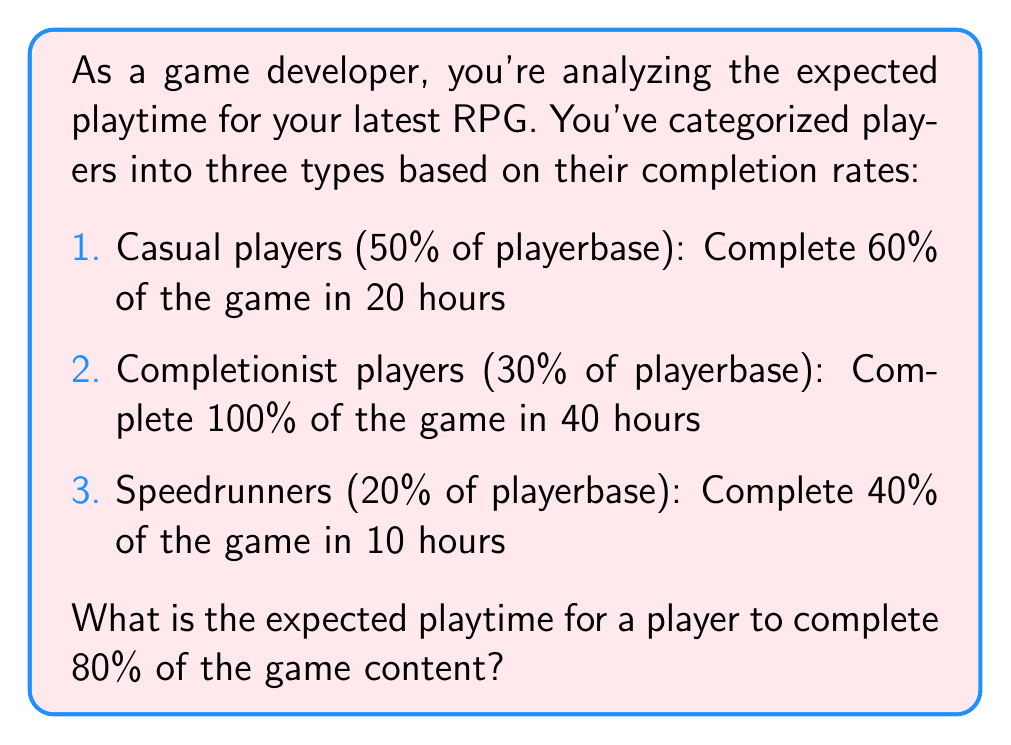Show me your answer to this math problem. Let's approach this step-by-step:

1) First, we need to calculate the completion rate per hour for each player type:

   Casual: $\frac{60\%}{20 \text{ hours}} = 3\%$ per hour
   Completionist: $\frac{100\%}{40 \text{ hours}} = 2.5\%$ per hour
   Speedrunner: $\frac{40\%}{10 \text{ hours}} = 4\%$ per hour

2) Now, we can calculate how long it would take each player type to complete 80% of the game:

   Casual: $\frac{80\%}{3\% \text{ per hour}} = 26.67$ hours
   Completionist: $\frac{80\%}{2.5\% \text{ per hour}} = 32$ hours
   Speedrunner: $\frac{80\%}{4\% \text{ per hour}} = 20$ hours

3) To calculate the expected playtime, we need to weight these times by the proportion of each player type:

   $E(\text{playtime}) = 0.5 \times 26.67 + 0.3 \times 32 + 0.2 \times 20$

4) Let's compute this:

   $E(\text{playtime}) = 13.335 + 9.6 + 4 = 26.935$ hours

Thus, the expected playtime for a player to complete 80% of the game content is approximately 26.94 hours.
Answer: 26.94 hours 